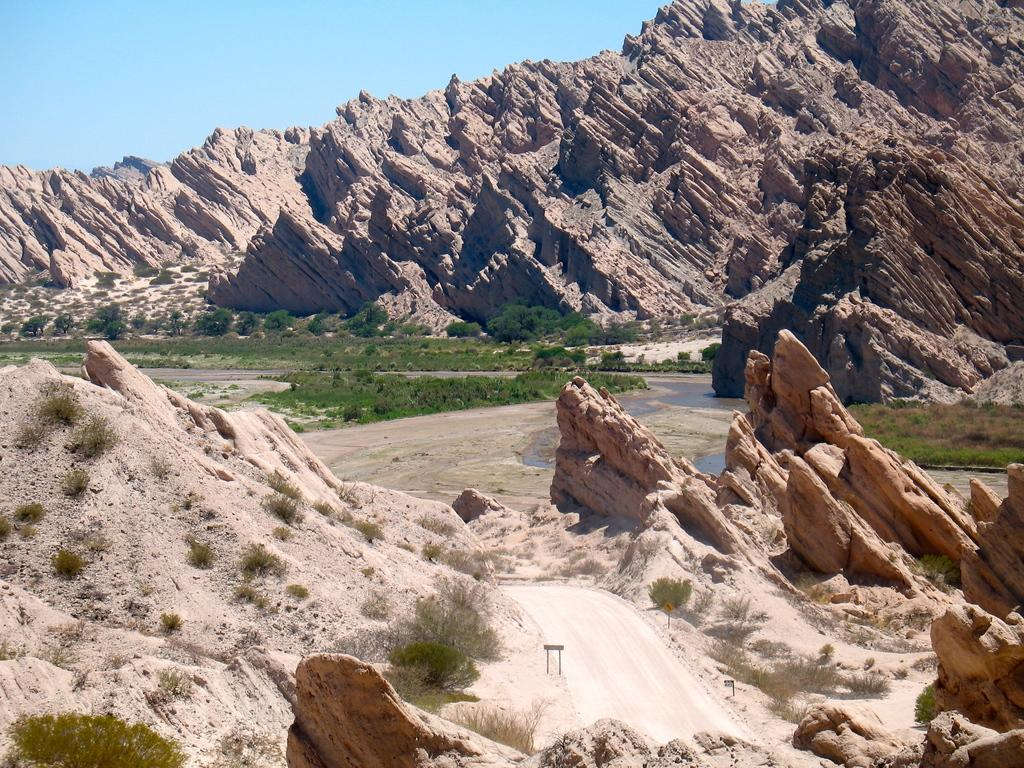What is located at the bottom of the image? There is a path at the bottom of the image, along with rocks and plants. What can be seen on the ground at the bottom of the image? Rocks and plants are present on the ground at the bottom of the image. What is visible in the background of the image? Water, trees, grass, a mountain, and the sky are visible in the background of the image. What type of belief is being expressed by the actor in the image? There is no actor present in the image, and therefore no belief can be expressed. How many trucks are visible in the image? There are no trucks visible in the image. 